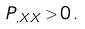<formula> <loc_0><loc_0><loc_500><loc_500>P _ { , X X } > 0 \, .</formula> 